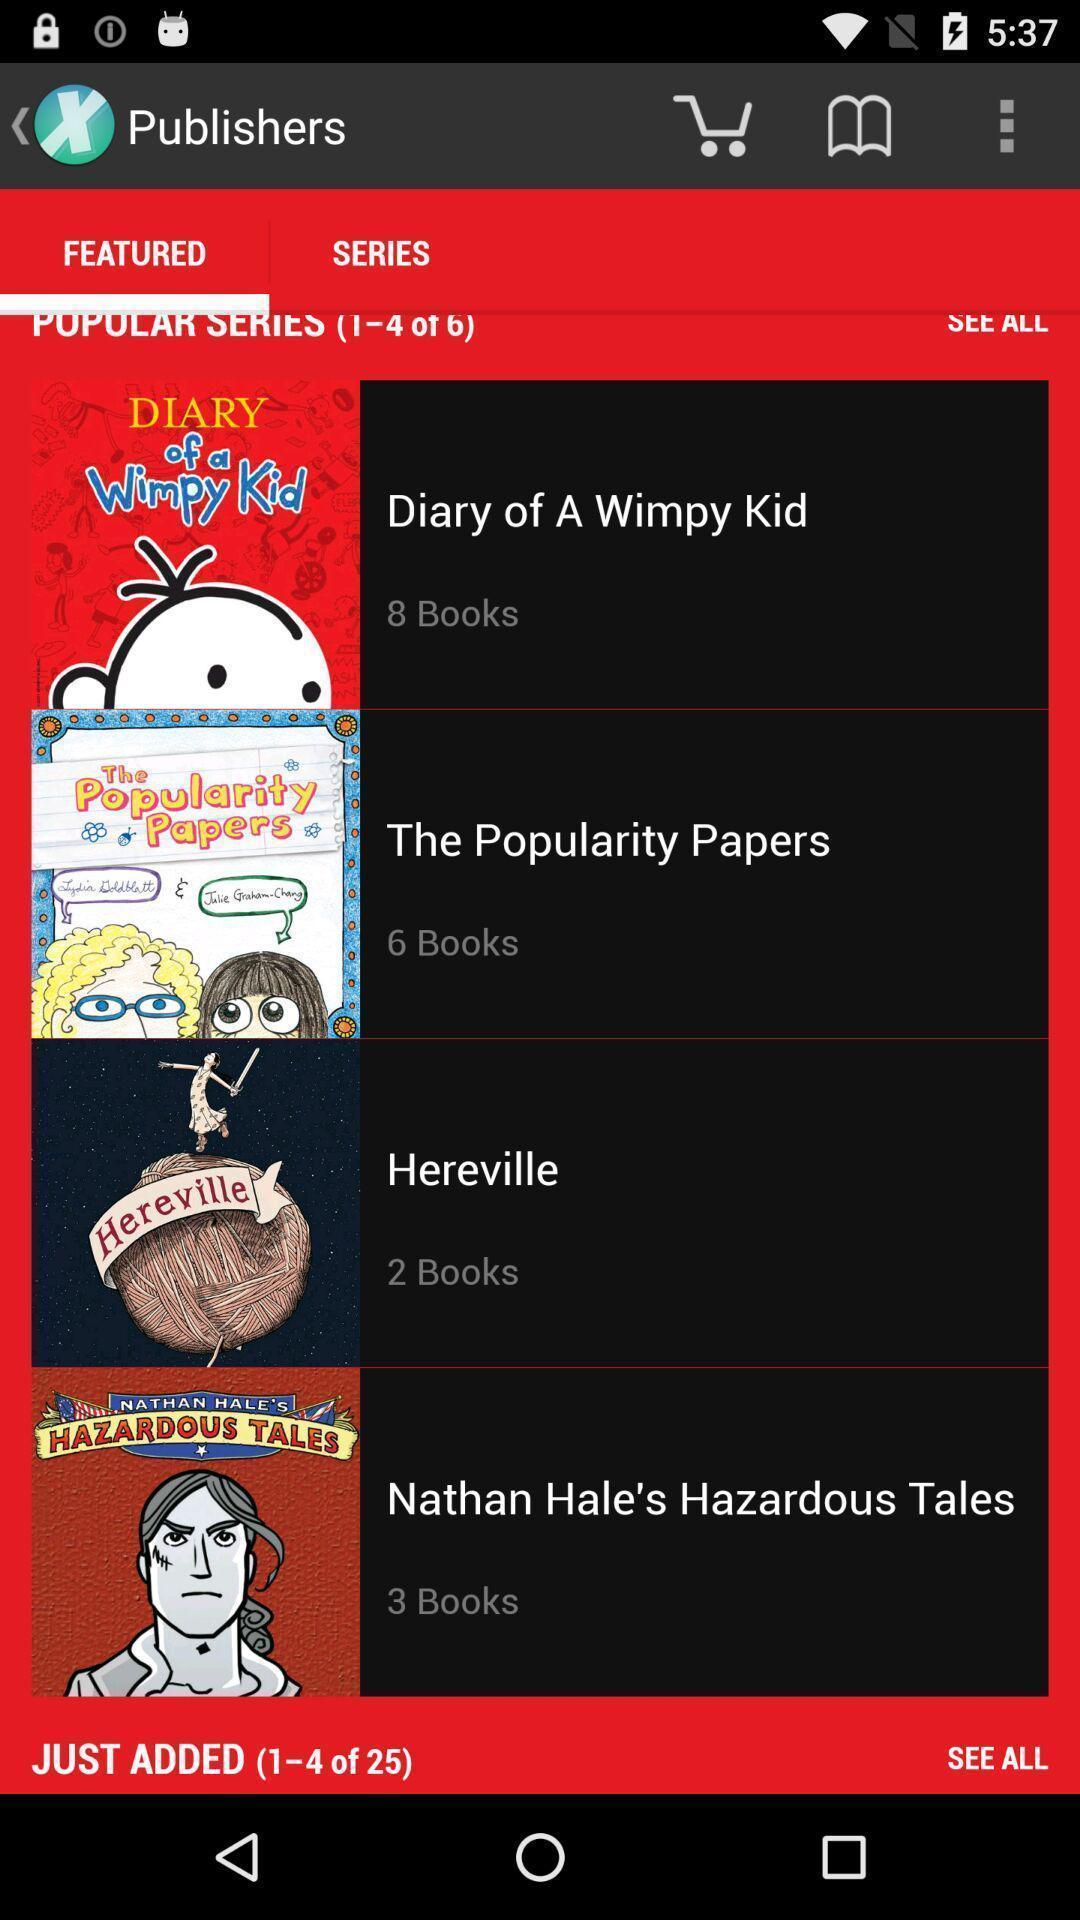What details can you identify in this image? Screen displaying a list of books with names and posters. 